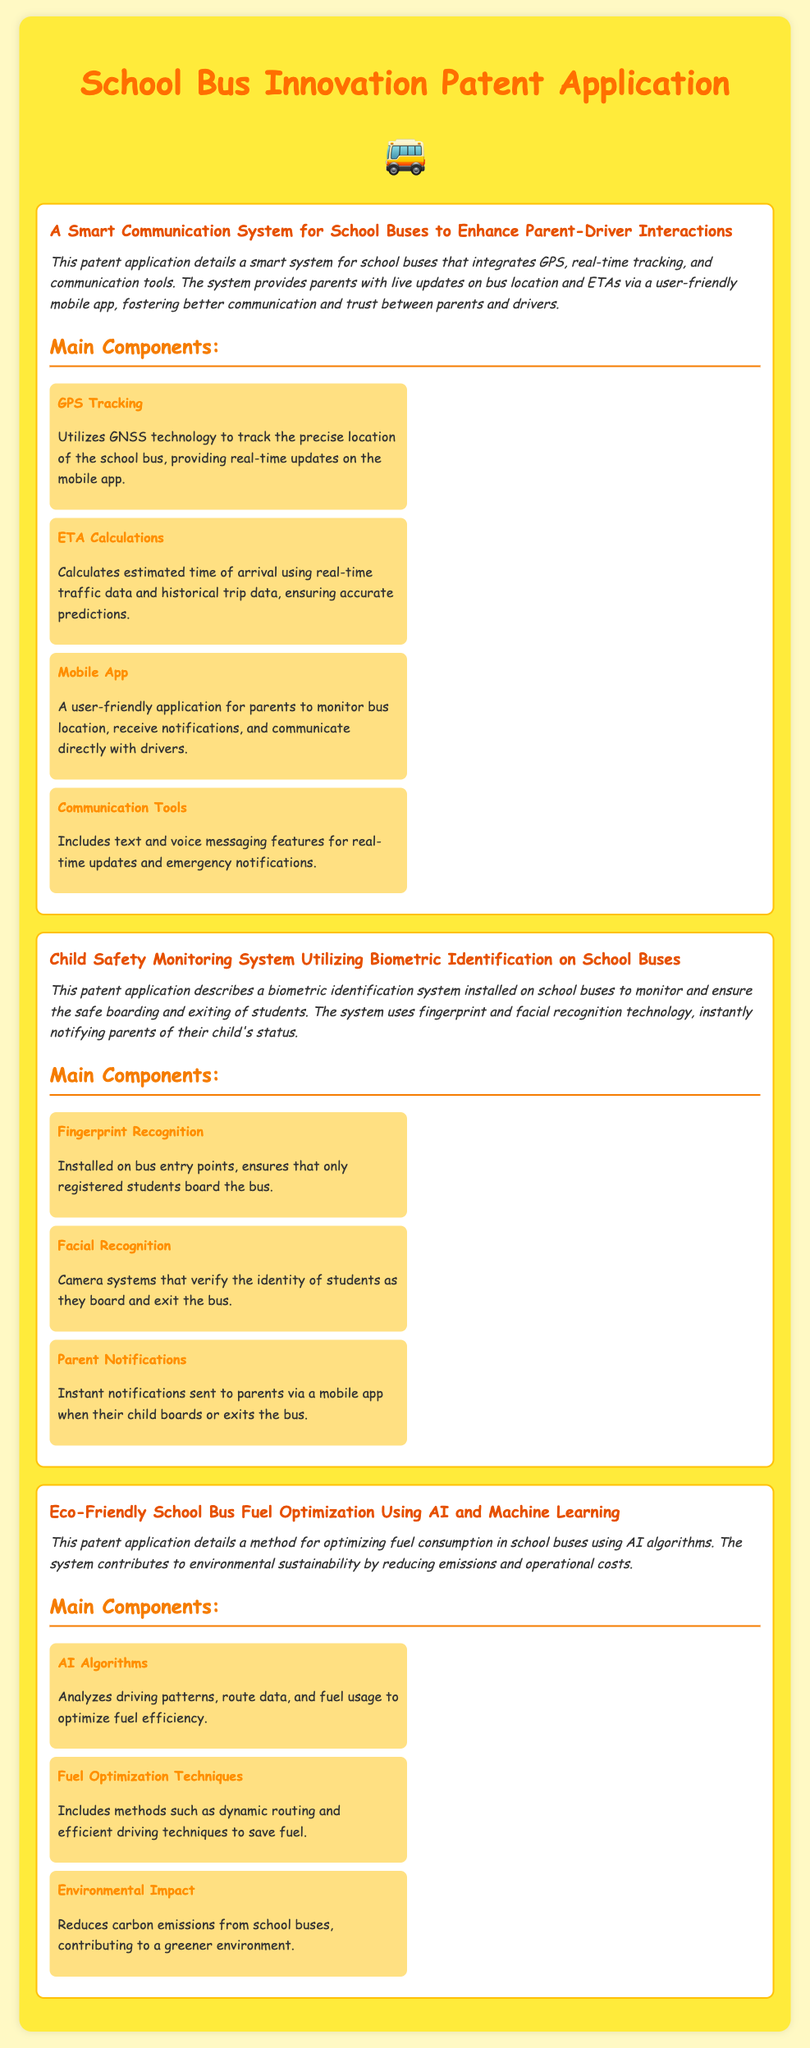What is the title of the first patent? The document begins with the title of the first patent application related to school buses.
Answer: A Smart Communication System for School Buses to Enhance Parent-Driver Interactions What technology is used for tracking bus location? The document specifies the technology employed in the smart communication system to track the bus location.
Answer: GNSS technology What is one of the functionalities of the mobile app? The document describes the capabilities of the mobile app included in the smart communication system.
Answer: Monitor bus location How does the Child Safety Monitoring System notify parents? The document outlines how parents are informed when their child interacts with the system.
Answer: Instant notifications What is the purpose of the eco-friendly fuel optimization system? The document states the main objective of employing AI for fuel optimization in school buses.
Answer: Reducing emissions How does the Adaptive Suspension System enhance passenger experience? The document implies how the suspension system contributes to the comfort of passengers based on specific conditions.
Answer: Ensuring a smoother ride What is a main component of the biometric identification system? The document lists the essential elements included in the child safety monitoring system for identifying students.
Answer: Fingerprint Recognition What is one way the AI algorithms optimize fuel consumption? The document explains one method used by AI to achieve fuel efficiency in school buses.
Answer: Analyzes driving patterns Which school bus patent focuses on educational content? The document outlines various patents but indicates a specific one focused on educational enhancements within school buses.
Answer: Interactive Educational Display Systems for School Buses 